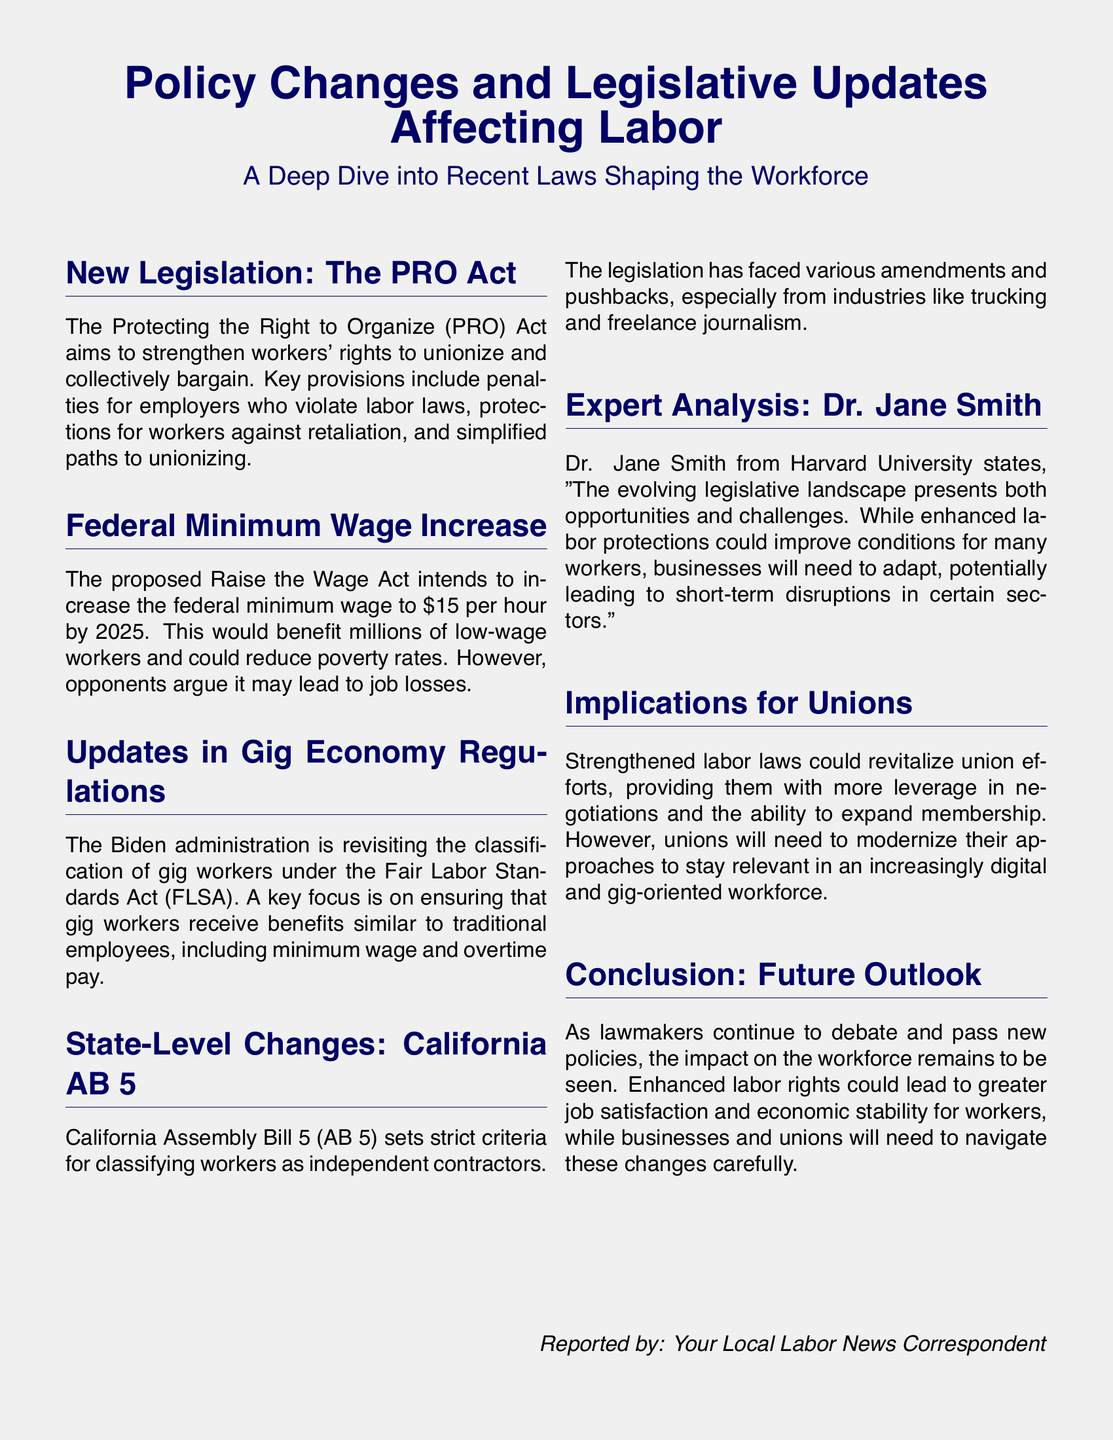What is the title of the legislation aimed at strengthening workers' rights? The title of the legislation is mentioned as the Protecting the Right to Organize Act.
Answer: Protecting the Right to Organize Act What is the proposed federal minimum wage by 2025? The proposed federal minimum wage is stated as 15 dollars per hour.
Answer: 15 dollars per hour What is the focus of the updates in gig economy regulations? The focus of the updates is on ensuring gig workers receive benefits similar to traditional employees.
Answer: Benefits similar to traditional employees What is California Assembly Bill 5 also known as? California Assembly Bill 5 is commonly referred to as AB 5.
Answer: AB 5 Who provided the expert analysis in the document? The expert analysis was provided by Dr. Jane Smith.
Answer: Dr. Jane Smith What could strengthened labor laws lead to in terms of union efforts? Strengthened labor laws could revitalize union efforts, providing more leverage in negotiations.
Answer: Revitalize union efforts What is the potential impact of the proposed Raise the Wage Act on poverty rates? The potential impact mentioned is a reduction in poverty rates.
Answer: Reduction in poverty rates What does the document suggest about future job satisfaction? The document suggests enhanced labor rights could lead to greater job satisfaction.
Answer: Greater job satisfaction 